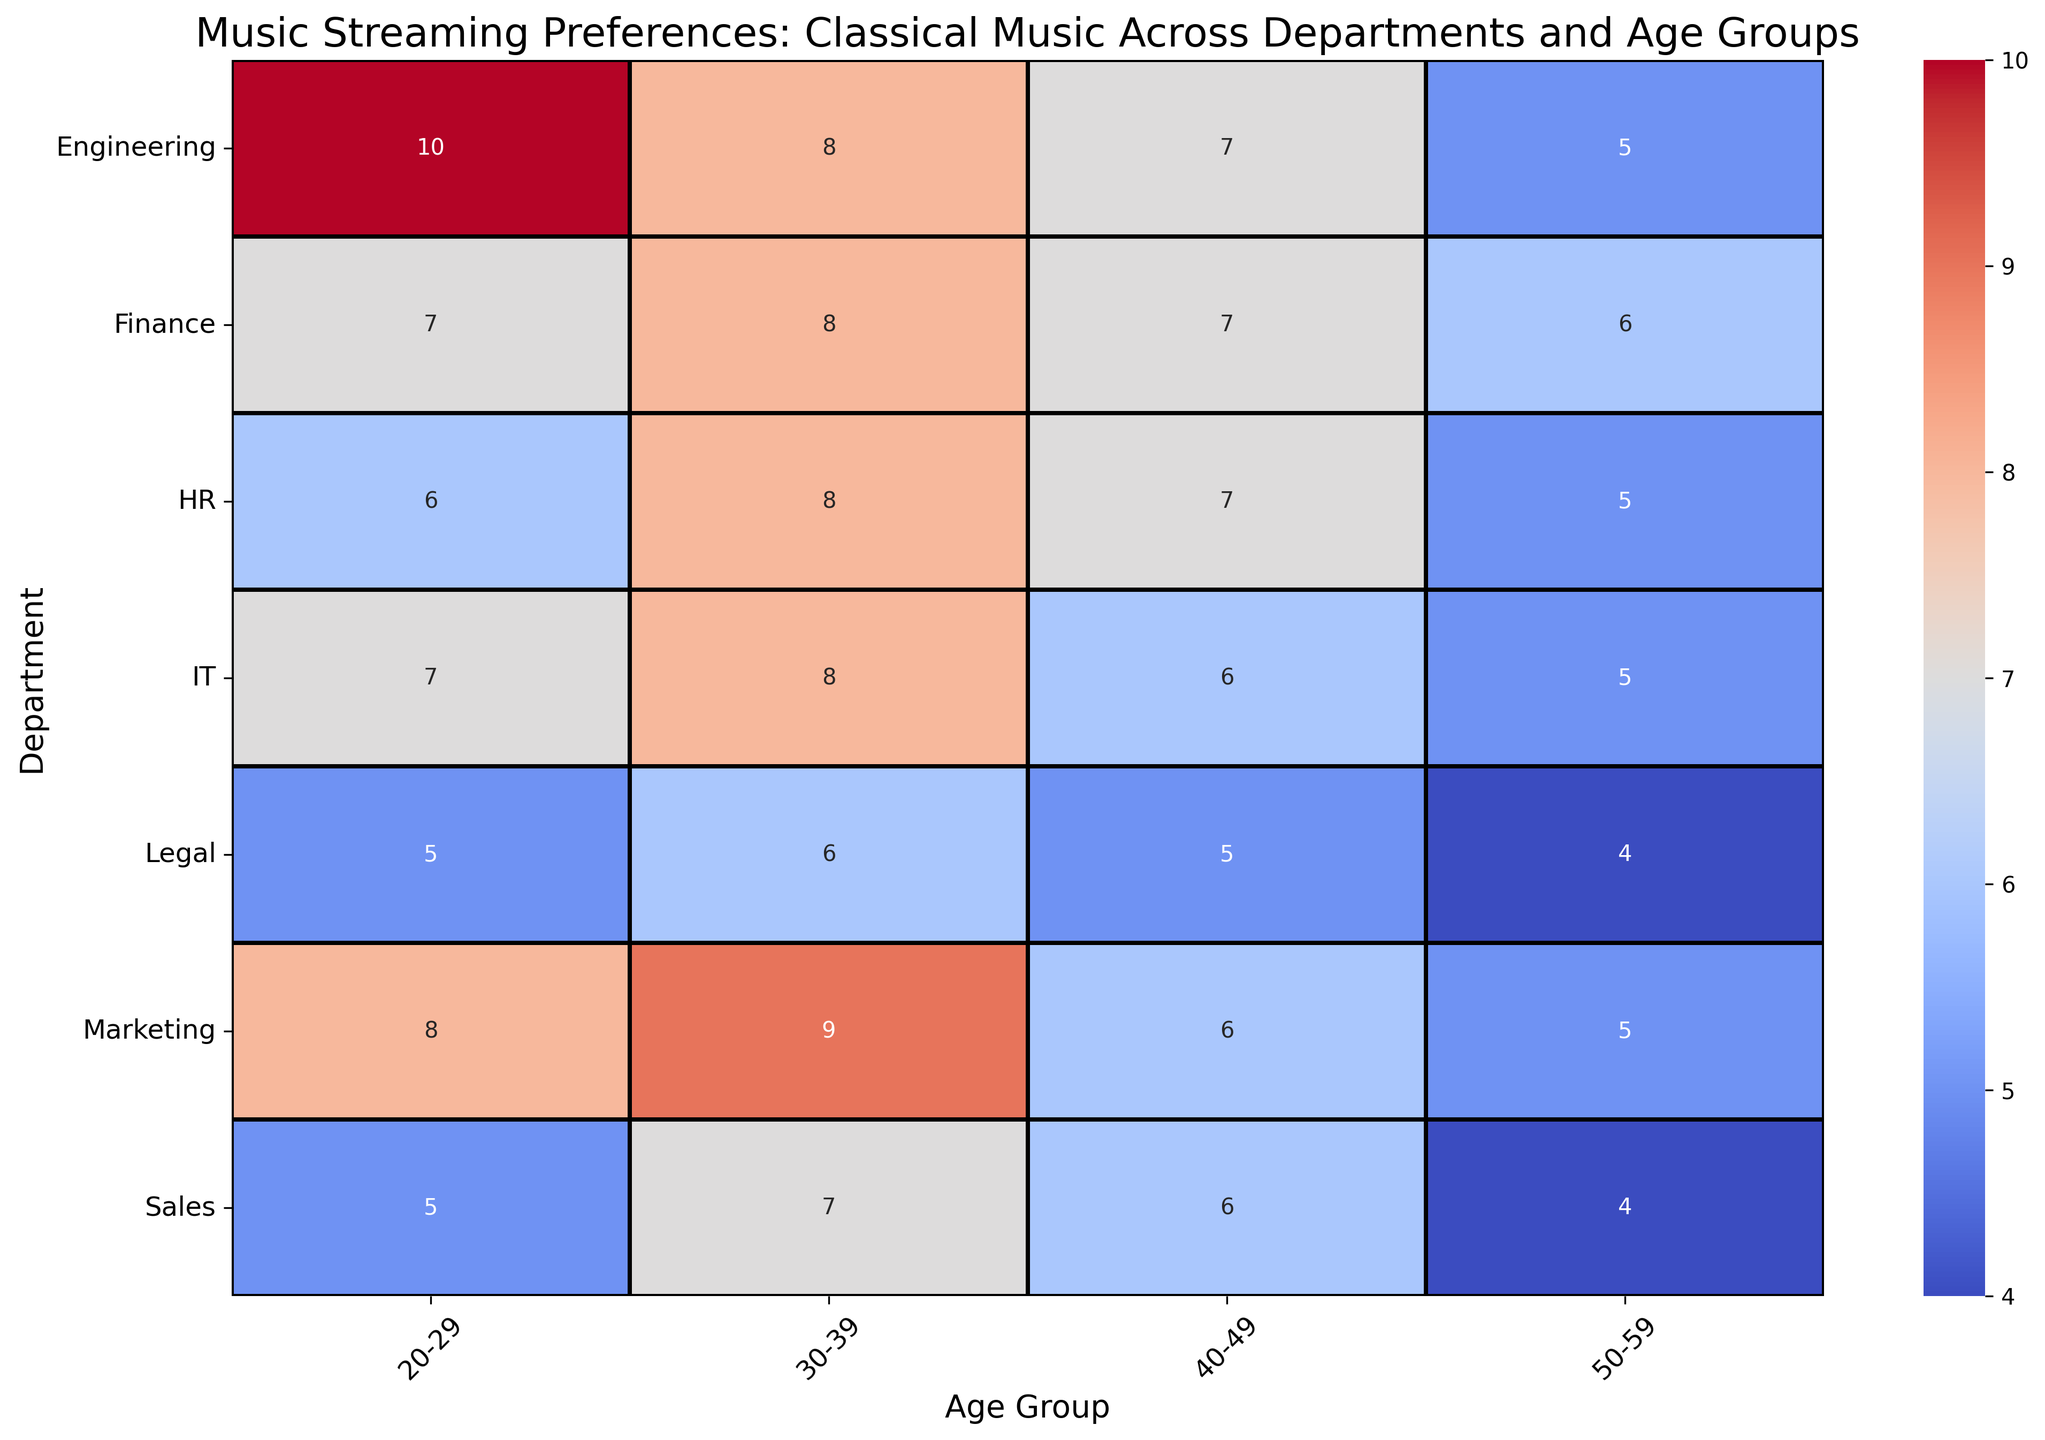What's the age group with the highest preference for Classical music in the Engineering department? From the figure, look for the Engineering row and identify the highest value across the different age groups for Classical music.
Answer: 20-29 Which department and age group combination shows the lowest preference for Classical music? Scan all the values in the heatmap to find the lowest number and note the corresponding department and age group.
Answer: Sales, 50-59 Compare the preference for Classical music among employees aged 30-39 in the HR and IT departments. Which department has a higher value? Locate the values for age group 30-39 in both HR and IT rows, then compare the two values.
Answer: IT What is the sum of preferences for Classical music in the 40-49 age group across all departments? Add up the values for age group 40-49 from each department row.
Answer: 38 Which age group in the Sales department has a preference closely matching the 50-59 age group's preference in the Engineering department? Compare the value of 50-59 in Engineering to the values in all age groups for Sales and identify the closest one.
Answer: 30-39 Which department shows a consistent decrease in preference for Classical music as age increases? Inspect the pattern in each department's row to see if values steadily decrease from one age group to the next.
Answer: Legal How does the preference for Classical music in the 20-29 age group of the Finance department compare to that of the Marketing department? Directly compare the value of the 20-29 age group in Finance to the value in Marketing.
Answer: Marketing is higher What is the average preference for Classical music among employees aged 50-59 across all departments? Sum the values for age group 50-59 from each department row, then divide by the number of departments (7).
Answer: 4.857 Identify the department whose youngest age group (20-29) shows a preference for Classical music comparable to the oldest age group (50-59) in the HR department. Compare the value of 50-59 in HR to the values of 20-29 in all departments and find the closest match.
Answer: Finance 